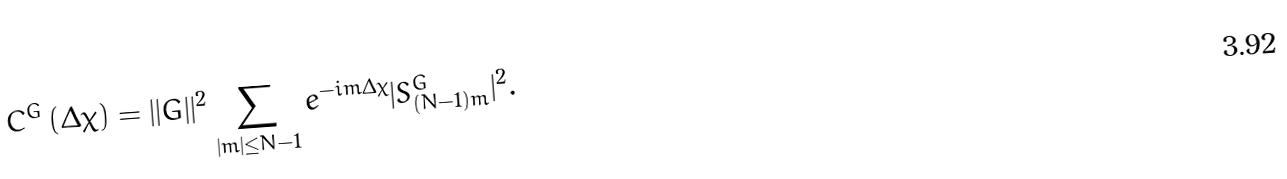Convert formula to latex. <formula><loc_0><loc_0><loc_500><loc_500>C ^ { G } \left ( \Delta \chi \right ) = | | G | | ^ { 2 } \sum _ { | m | \leq N - 1 } e ^ { - i m \Delta \chi } | S _ { ( N - 1 ) m } ^ { G } | ^ { 2 } .</formula> 